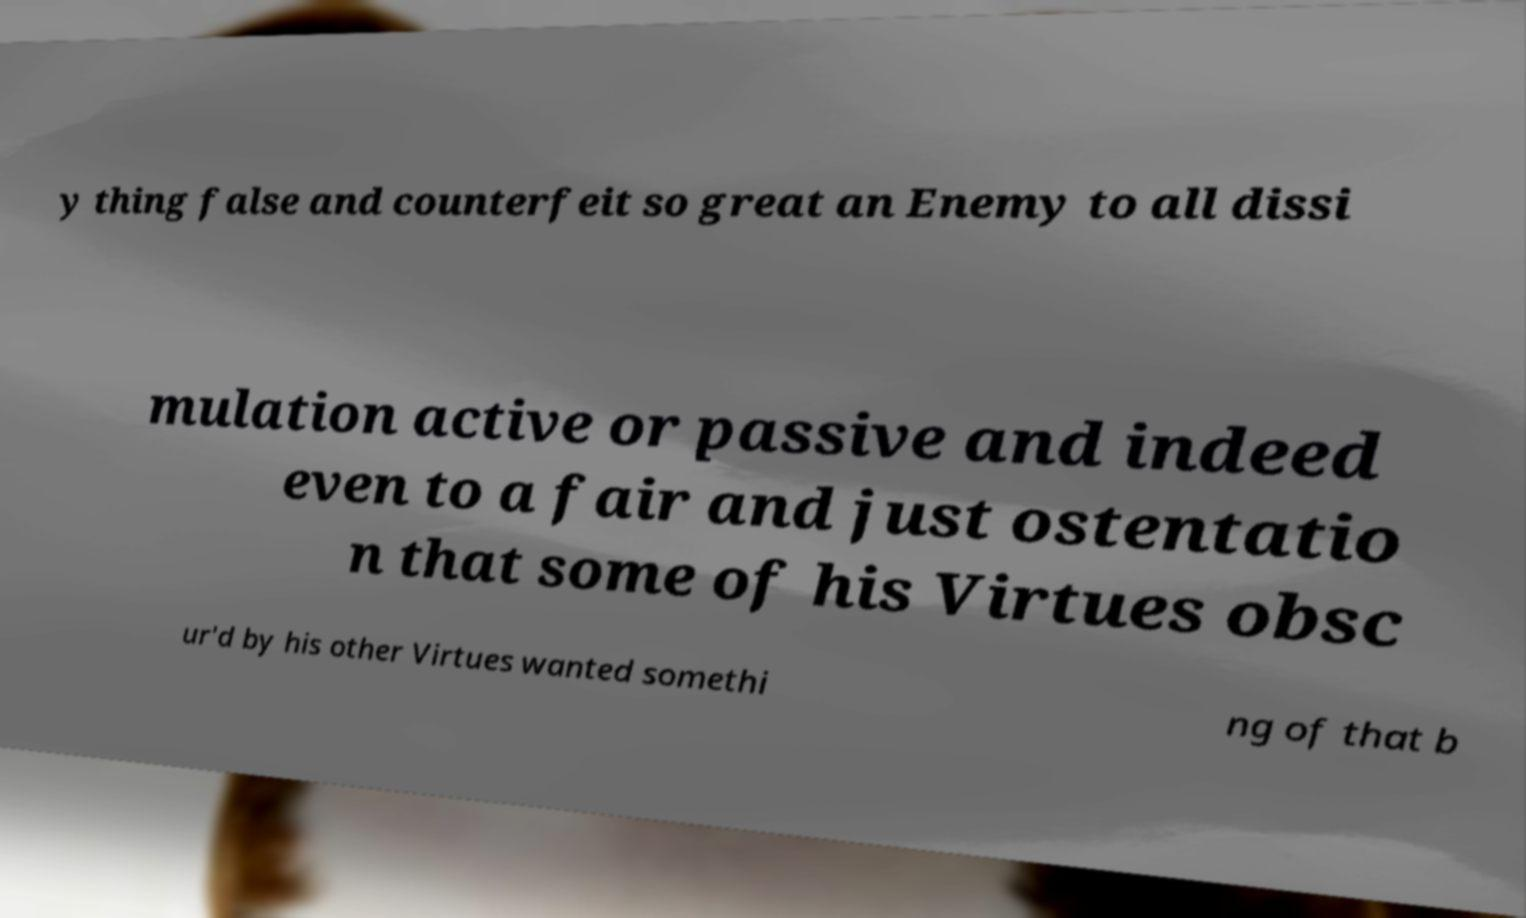Could you assist in decoding the text presented in this image and type it out clearly? y thing false and counterfeit so great an Enemy to all dissi mulation active or passive and indeed even to a fair and just ostentatio n that some of his Virtues obsc ur'd by his other Virtues wanted somethi ng of that b 